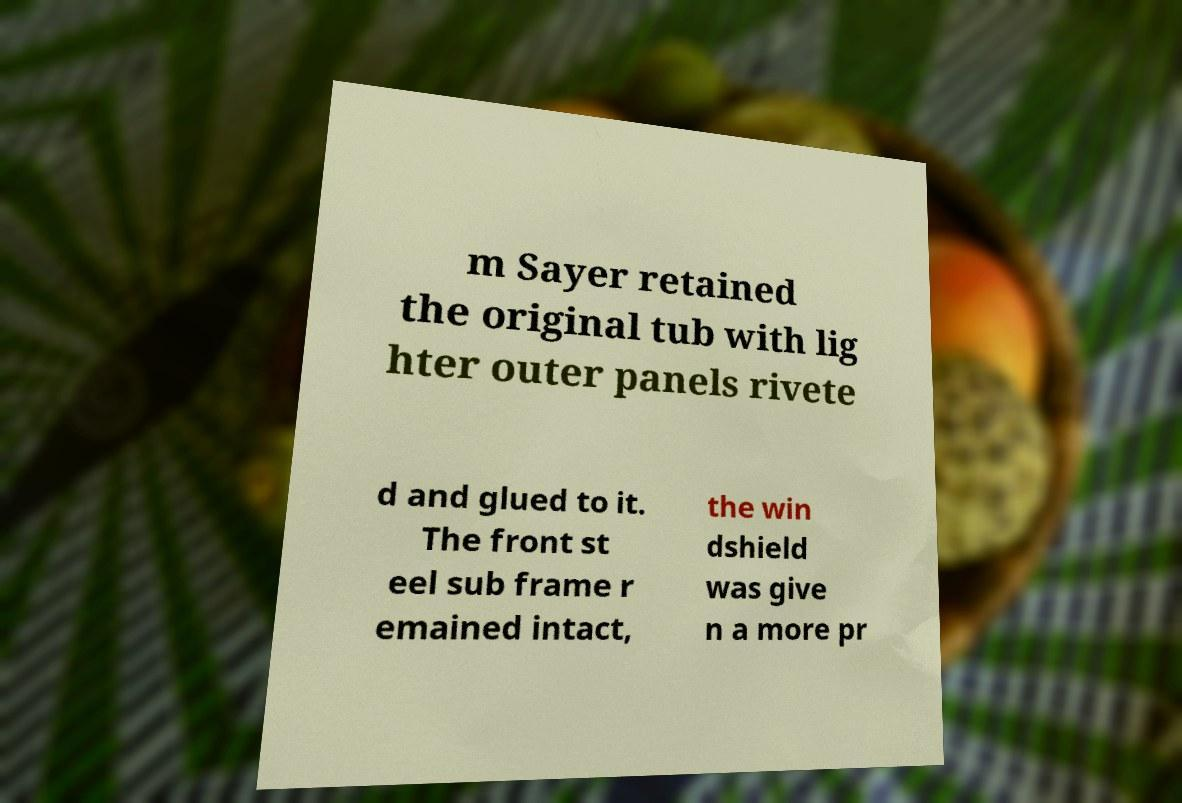Please identify and transcribe the text found in this image. m Sayer retained the original tub with lig hter outer panels rivete d and glued to it. The front st eel sub frame r emained intact, the win dshield was give n a more pr 